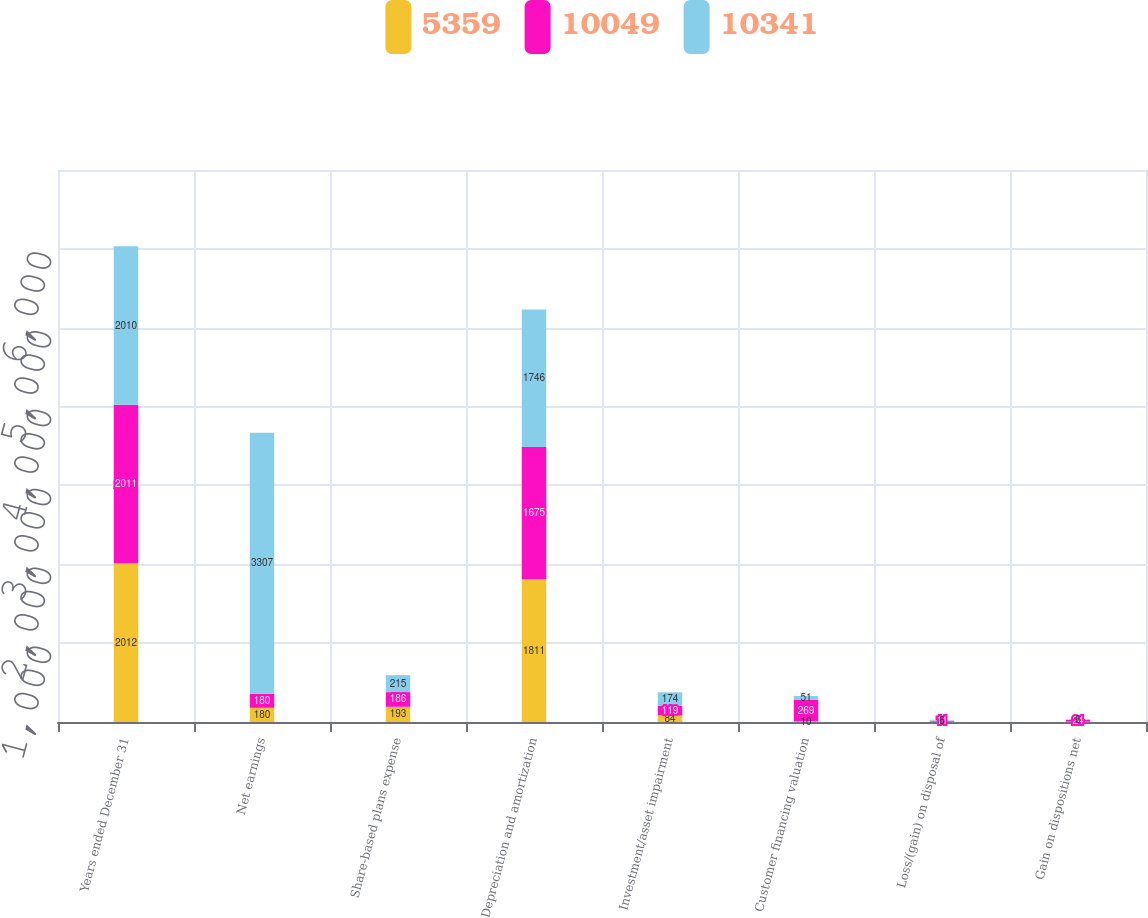<chart> <loc_0><loc_0><loc_500><loc_500><stacked_bar_chart><ecel><fcel>Years ended December 31<fcel>Net earnings<fcel>Share-based plans expense<fcel>Depreciation and amortization<fcel>Investment/asset impairment<fcel>Customer financing valuation<fcel>Loss/(gain) on disposal of<fcel>Gain on dispositions net<nl><fcel>5359<fcel>2012<fcel>180<fcel>193<fcel>1811<fcel>84<fcel>10<fcel>5<fcel>4<nl><fcel>10049<fcel>2011<fcel>180<fcel>186<fcel>1675<fcel>119<fcel>269<fcel>11<fcel>24<nl><fcel>10341<fcel>2010<fcel>3307<fcel>215<fcel>1746<fcel>174<fcel>51<fcel>6<fcel>6<nl></chart> 